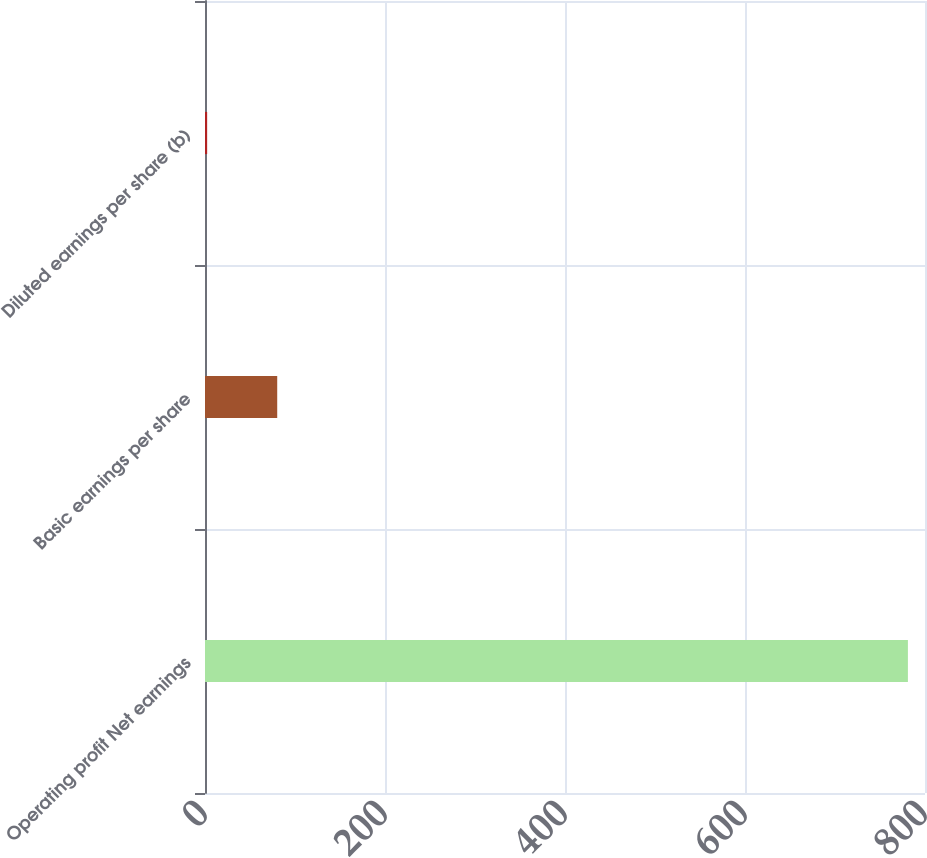Convert chart. <chart><loc_0><loc_0><loc_500><loc_500><bar_chart><fcel>Operating profit Net earnings<fcel>Basic earnings per share<fcel>Diluted earnings per share (b)<nl><fcel>781<fcel>80.24<fcel>2.38<nl></chart> 